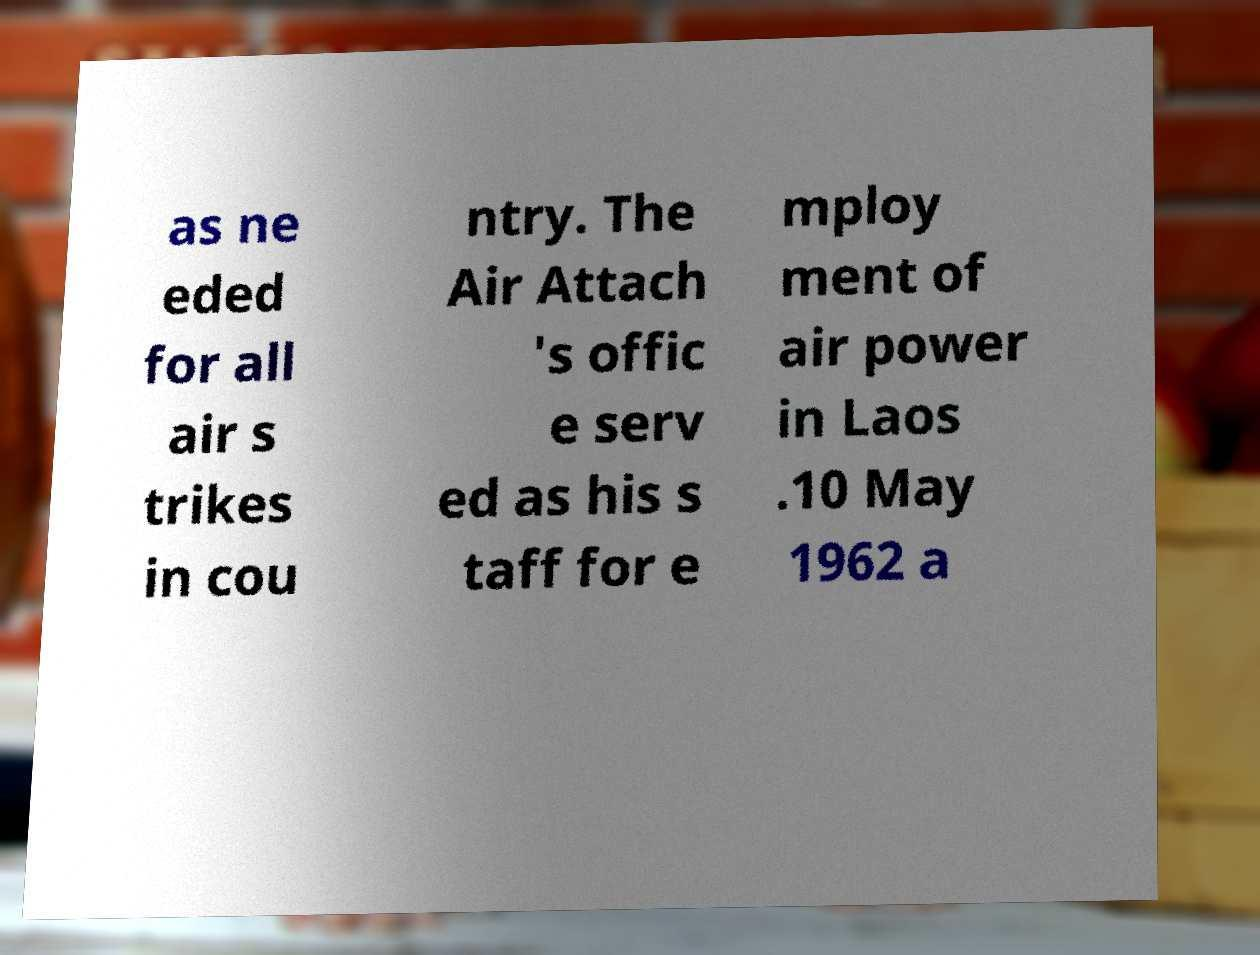For documentation purposes, I need the text within this image transcribed. Could you provide that? as ne eded for all air s trikes in cou ntry. The Air Attach 's offic e serv ed as his s taff for e mploy ment of air power in Laos .10 May 1962 a 